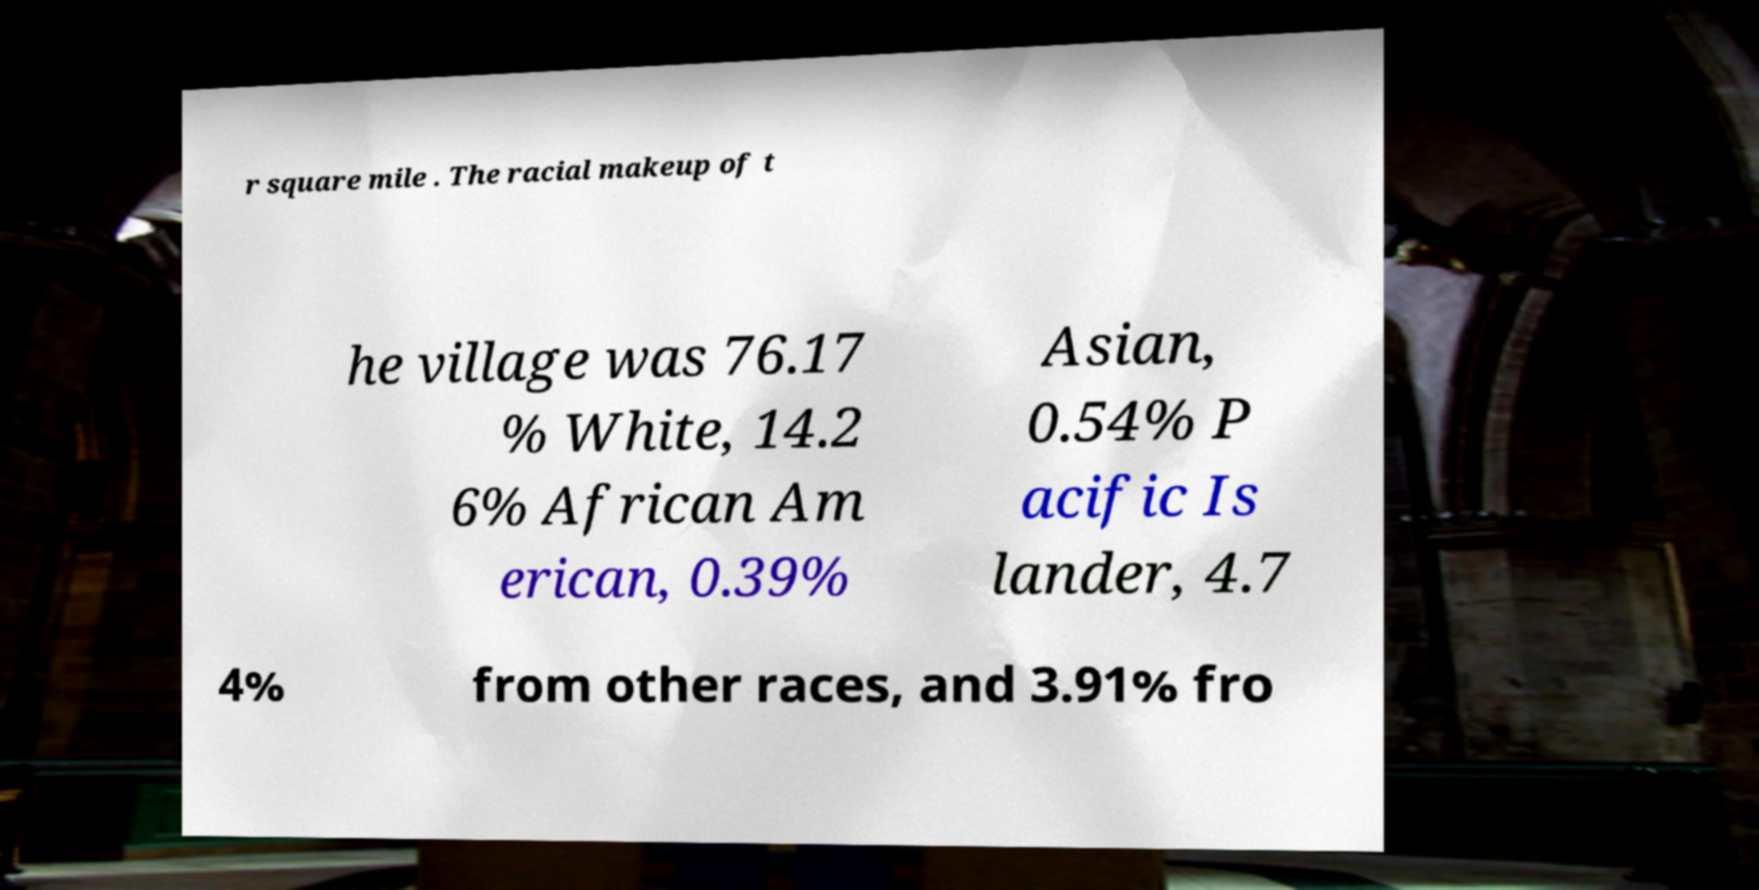For documentation purposes, I need the text within this image transcribed. Could you provide that? r square mile . The racial makeup of t he village was 76.17 % White, 14.2 6% African Am erican, 0.39% Asian, 0.54% P acific Is lander, 4.7 4% from other races, and 3.91% fro 